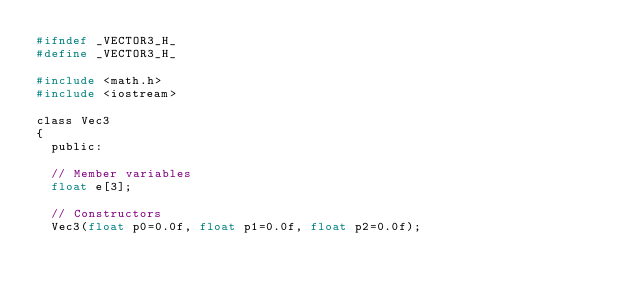<code> <loc_0><loc_0><loc_500><loc_500><_C_>#ifndef _VECTOR3_H_
#define _VECTOR3_H_

#include <math.h>
#include <iostream>

class Vec3
{
	public:

	// Member variables	
	float e[3];

	// Constructors
	Vec3(float p0=0.0f, float p1=0.0f, float p2=0.0f);</code> 